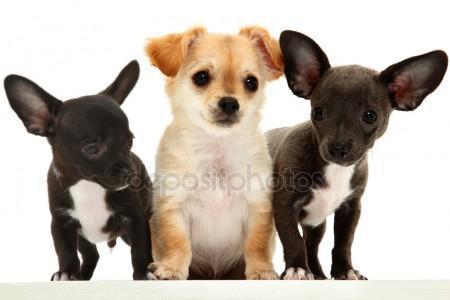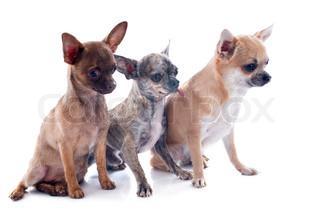The first image is the image on the left, the second image is the image on the right. Given the left and right images, does the statement "There are more dogs in the image on the right." hold true? Answer yes or no. No. The first image is the image on the left, the second image is the image on the right. Evaluate the accuracy of this statement regarding the images: "One image contains three small dogs, and the other image contains four small dogs.". Is it true? Answer yes or no. No. 